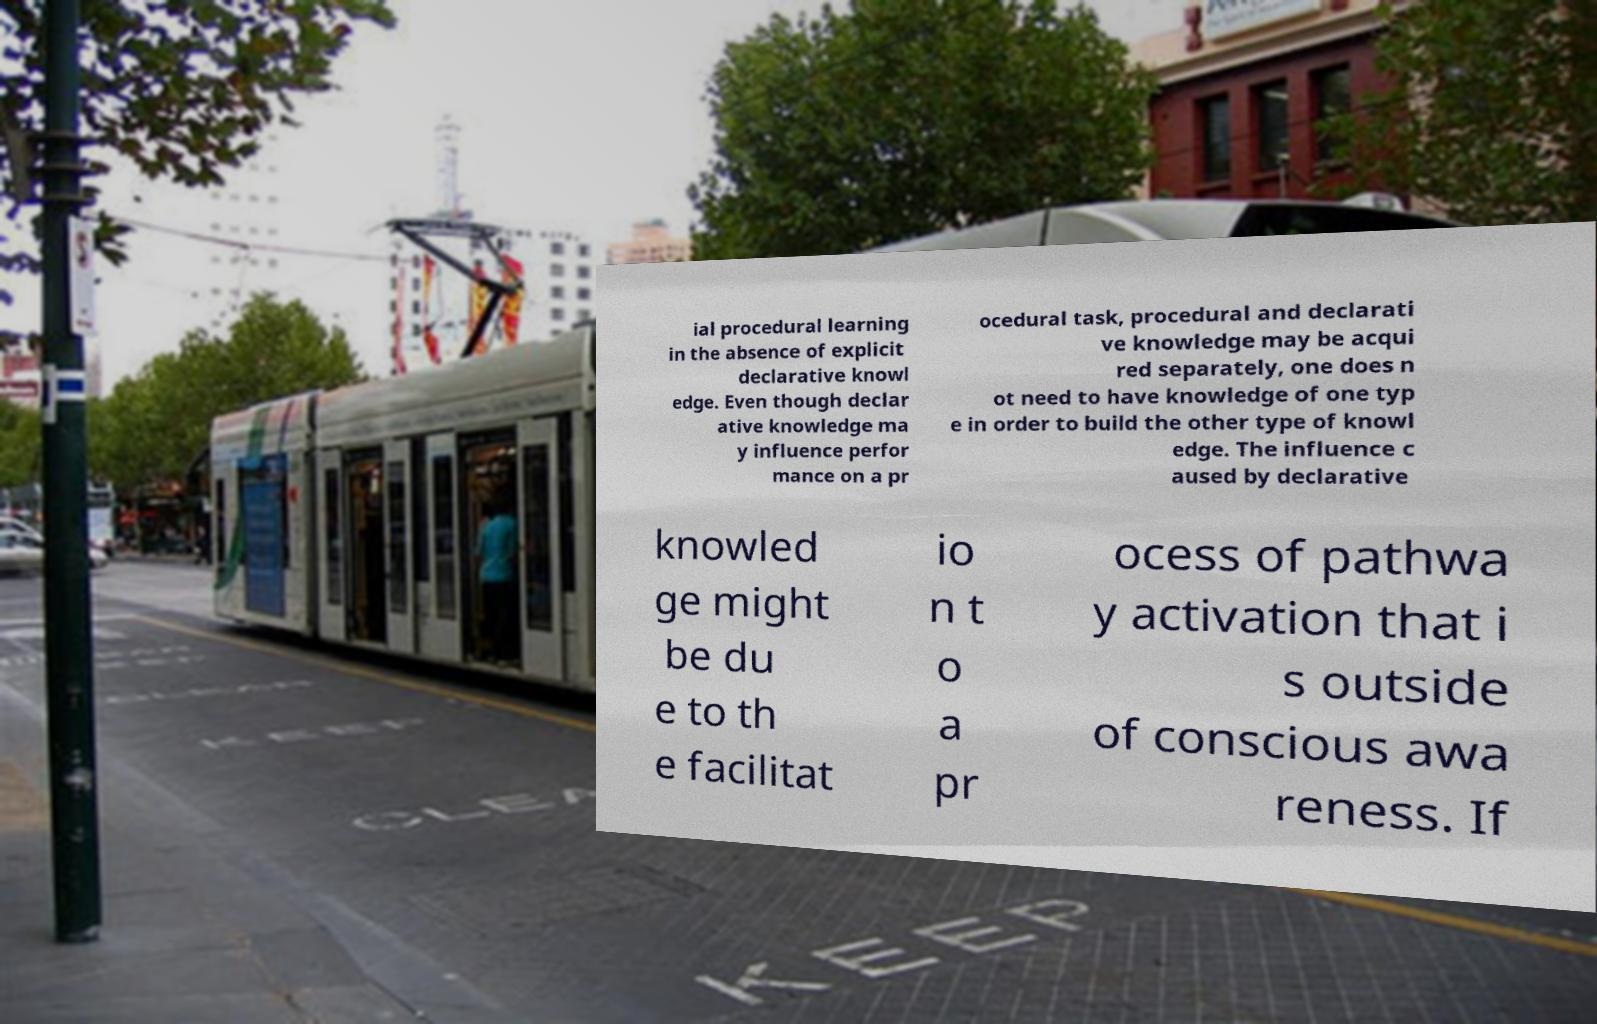Please read and relay the text visible in this image. What does it say? ial procedural learning in the absence of explicit declarative knowl edge. Even though declar ative knowledge ma y influence perfor mance on a pr ocedural task, procedural and declarati ve knowledge may be acqui red separately, one does n ot need to have knowledge of one typ e in order to build the other type of knowl edge. The influence c aused by declarative knowled ge might be du e to th e facilitat io n t o a pr ocess of pathwa y activation that i s outside of conscious awa reness. If 